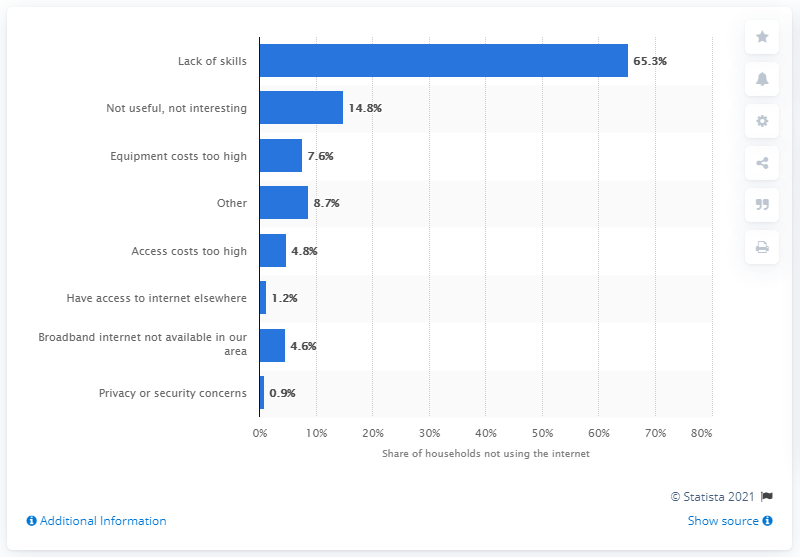Indicate a few pertinent items in this graphic. In the survey, it was found that 65.3% of households lacked the necessary ICT skills to access and use e-services effectively. 